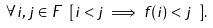Convert formula to latex. <formula><loc_0><loc_0><loc_500><loc_500>\forall i , j \in F \ [ i < j \implies f ( i ) < j \ ] .</formula> 